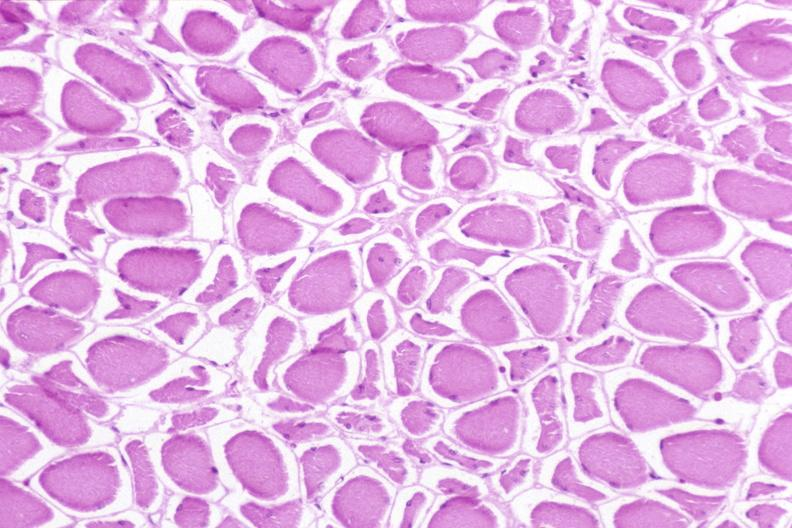does malaria plasmodium vivax show skeletal muscle, atrophy due to immobilization cast?
Answer the question using a single word or phrase. No 